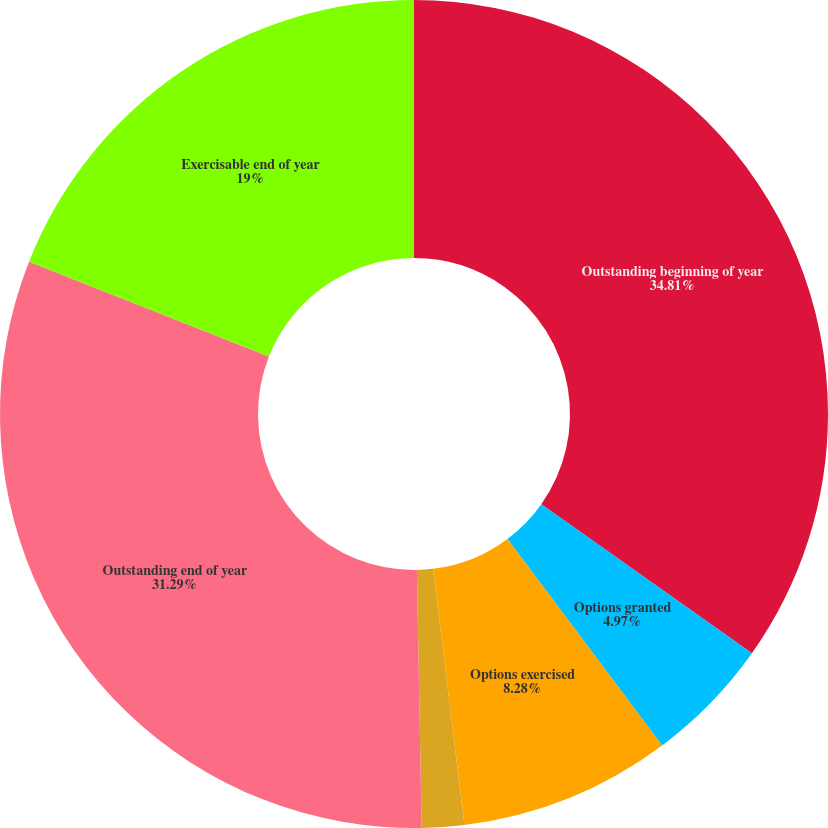Convert chart to OTSL. <chart><loc_0><loc_0><loc_500><loc_500><pie_chart><fcel>Outstanding beginning of year<fcel>Options granted<fcel>Options exercised<fcel>Options cancelled<fcel>Outstanding end of year<fcel>Exercisable end of year<nl><fcel>34.8%<fcel>4.97%<fcel>8.28%<fcel>1.65%<fcel>31.29%<fcel>19.0%<nl></chart> 